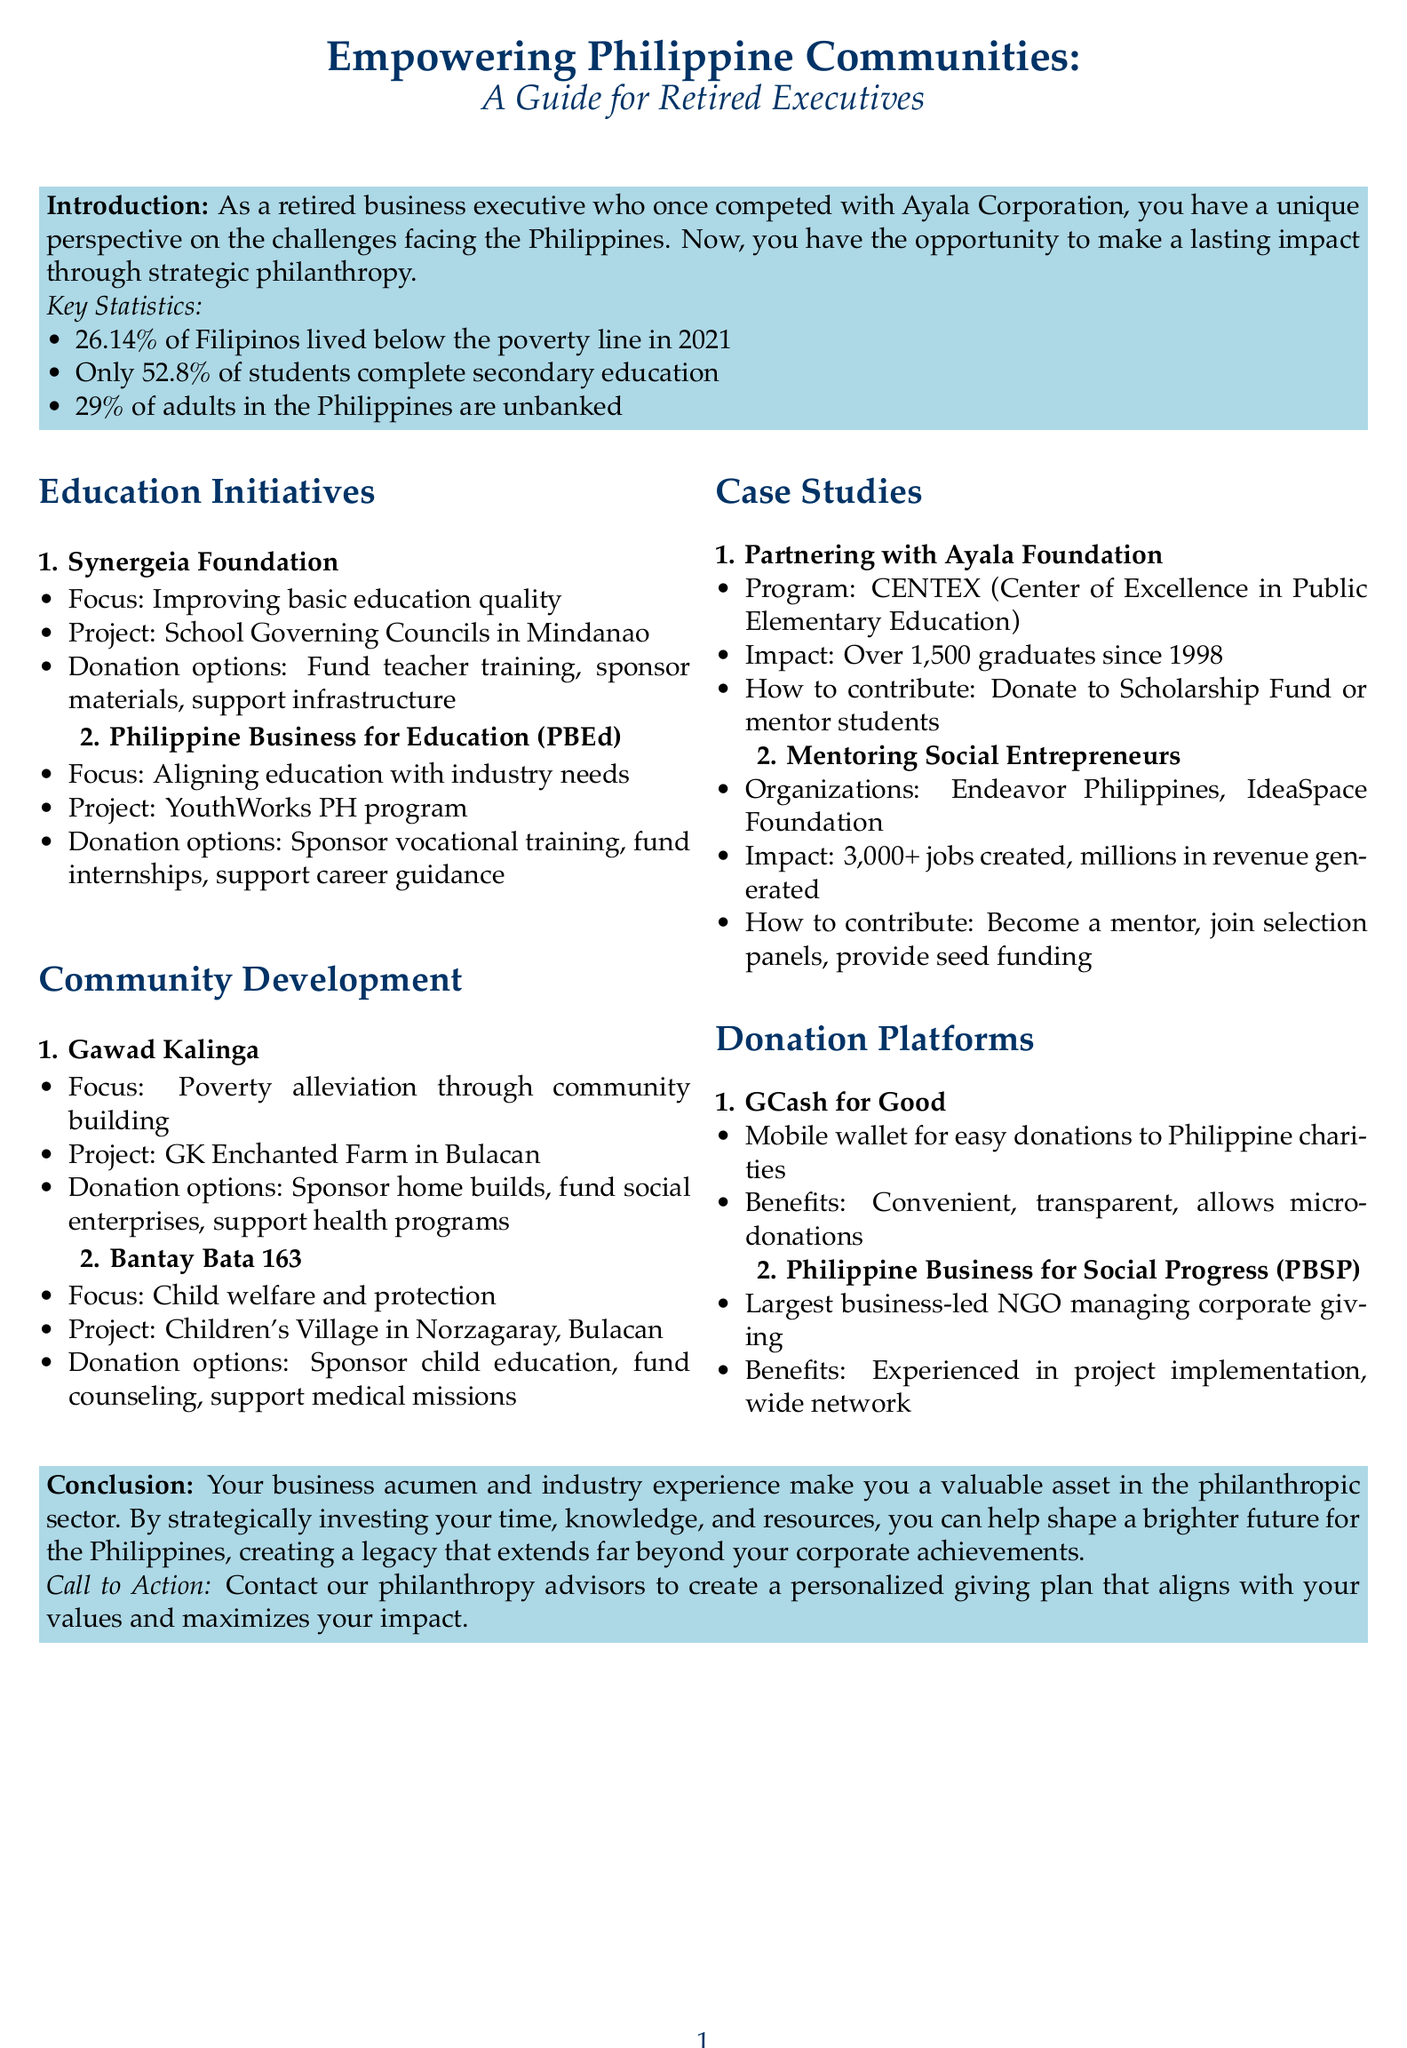What percentage of Filipinos lived below the poverty line in 2021? The document states that 26.14% of Filipinos lived below the poverty line in 2021.
Answer: 26.14% What is the focus of the Synergeia Foundation? The Synergeia Foundation focuses on improving basic education quality.
Answer: Improving basic education quality What is one donation option available for the Gawad Kalinga project? The document lists several donation options for Gawad Kalinga, including sponsoring a home build.
Answer: Sponsor a home build How many elementary school graduates has the CENTEX program produced since 1998? The CENTEX program has produced over 1,500 elementary school graduates since 1998.
Answer: Over 1,500 Which platform allows for micro-donations to various Philippine charities? The document mentions GCash for Good as a mobile wallet platform that allows for micro-donations.
Answer: GCash for Good What organization aligns education with industry needs? The document identifies the Philippine Business for Education (PBEd) as an organization that aligns education with industry needs.
Answer: Philippine Business for Education (PBEd) What impact do mentored startups create according to the document? The document states that mentored startups have created over 3,000 jobs and generated millions in revenue.
Answer: Over 3,000 jobs What is a key statistic regarding secondary education completion in the Philippines? The document mentions that only 52.8% of students complete secondary education.
Answer: 52.8% 